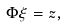<formula> <loc_0><loc_0><loc_500><loc_500>\Phi \xi = z ,</formula> 